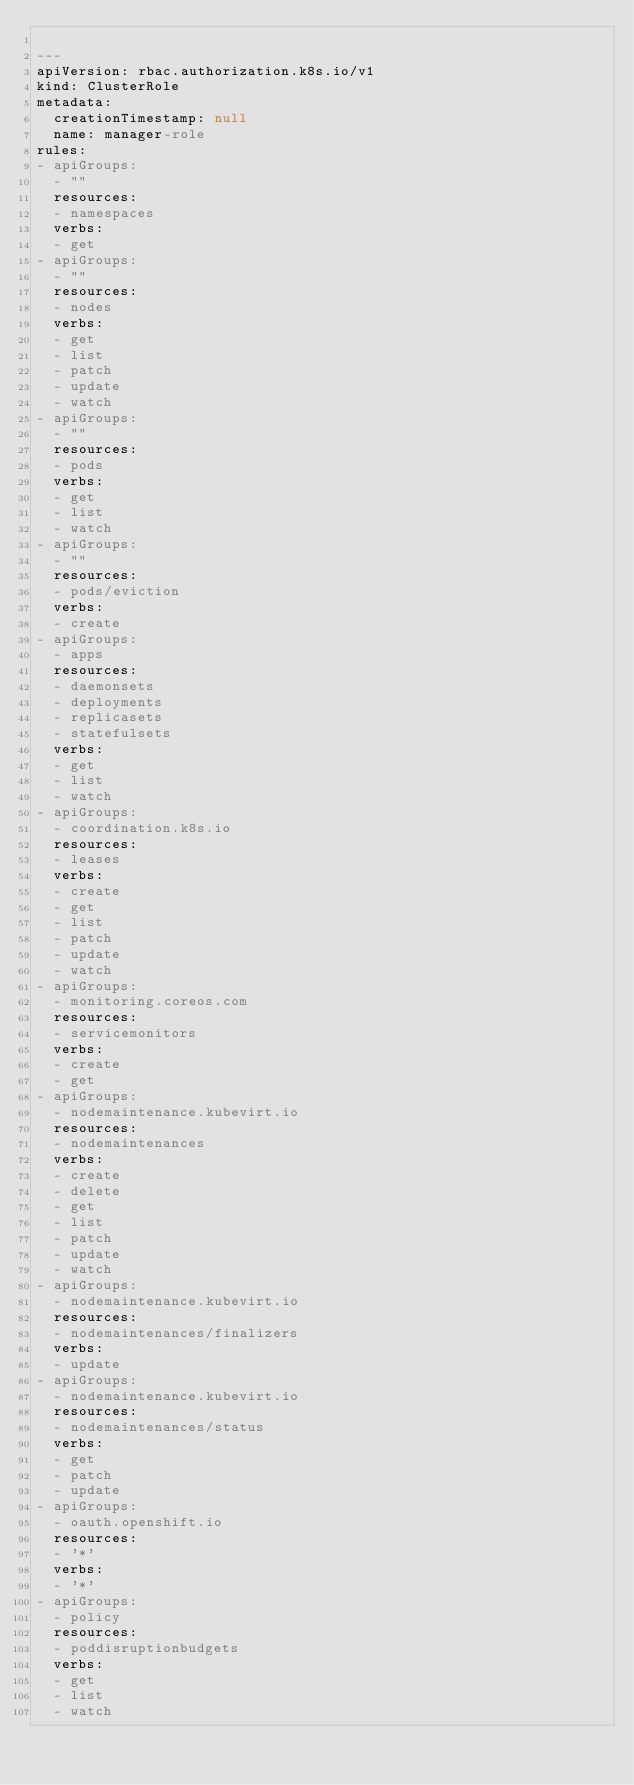Convert code to text. <code><loc_0><loc_0><loc_500><loc_500><_YAML_>
---
apiVersion: rbac.authorization.k8s.io/v1
kind: ClusterRole
metadata:
  creationTimestamp: null
  name: manager-role
rules:
- apiGroups:
  - ""
  resources:
  - namespaces
  verbs:
  - get
- apiGroups:
  - ""
  resources:
  - nodes
  verbs:
  - get
  - list
  - patch
  - update
  - watch
- apiGroups:
  - ""
  resources:
  - pods
  verbs:
  - get
  - list
  - watch
- apiGroups:
  - ""
  resources:
  - pods/eviction
  verbs:
  - create
- apiGroups:
  - apps
  resources:
  - daemonsets
  - deployments
  - replicasets
  - statefulsets
  verbs:
  - get
  - list
  - watch
- apiGroups:
  - coordination.k8s.io
  resources:
  - leases
  verbs:
  - create
  - get
  - list
  - patch
  - update
  - watch
- apiGroups:
  - monitoring.coreos.com
  resources:
  - servicemonitors
  verbs:
  - create
  - get
- apiGroups:
  - nodemaintenance.kubevirt.io
  resources:
  - nodemaintenances
  verbs:
  - create
  - delete
  - get
  - list
  - patch
  - update
  - watch
- apiGroups:
  - nodemaintenance.kubevirt.io
  resources:
  - nodemaintenances/finalizers
  verbs:
  - update
- apiGroups:
  - nodemaintenance.kubevirt.io
  resources:
  - nodemaintenances/status
  verbs:
  - get
  - patch
  - update
- apiGroups:
  - oauth.openshift.io
  resources:
  - '*'
  verbs:
  - '*'
- apiGroups:
  - policy
  resources:
  - poddisruptionbudgets
  verbs:
  - get
  - list
  - watch
</code> 